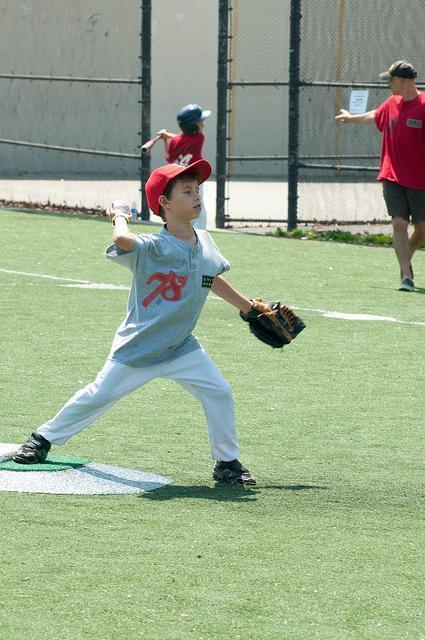How many people are visible?
Give a very brief answer. 2. 